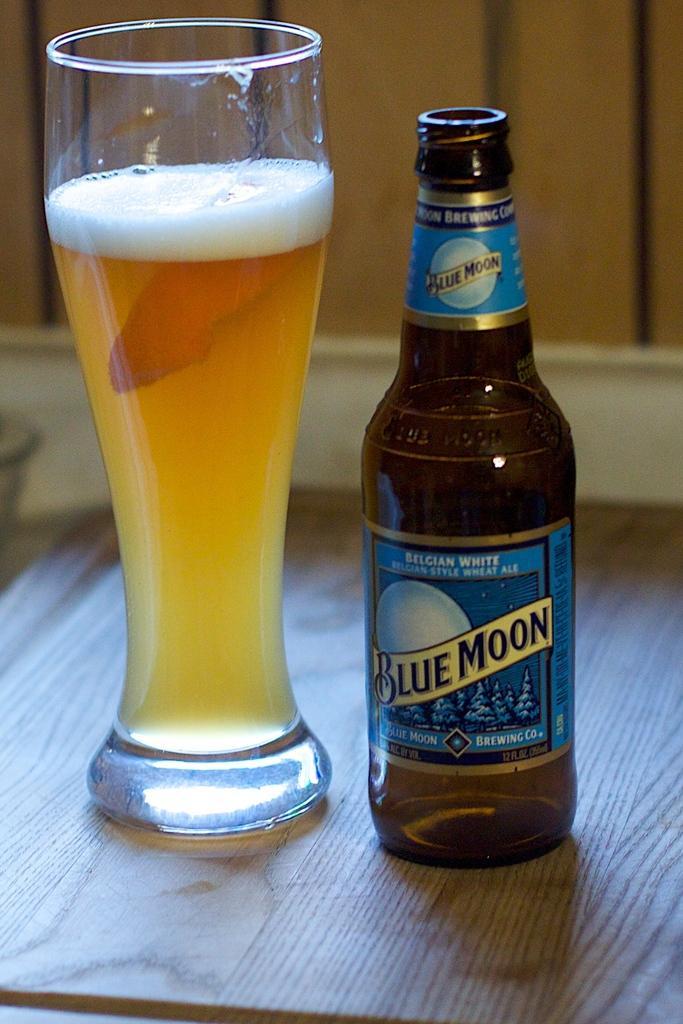In one or two sentences, can you explain what this image depicts? I can see in this image a glass bottle and glass on a table. The bottle has a name of "blue moon". 